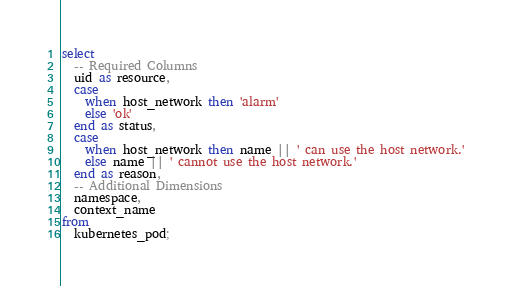Convert code to text. <code><loc_0><loc_0><loc_500><loc_500><_SQL_>select
  -- Required Columns
  uid as resource,
  case
    when host_network then 'alarm'
    else 'ok'
  end as status,
  case
    when host_network then name || ' can use the host network.'
    else name || ' cannot use the host network.'
  end as reason,
  -- Additional Dimensions
  namespace,
  context_name
from
  kubernetes_pod;</code> 